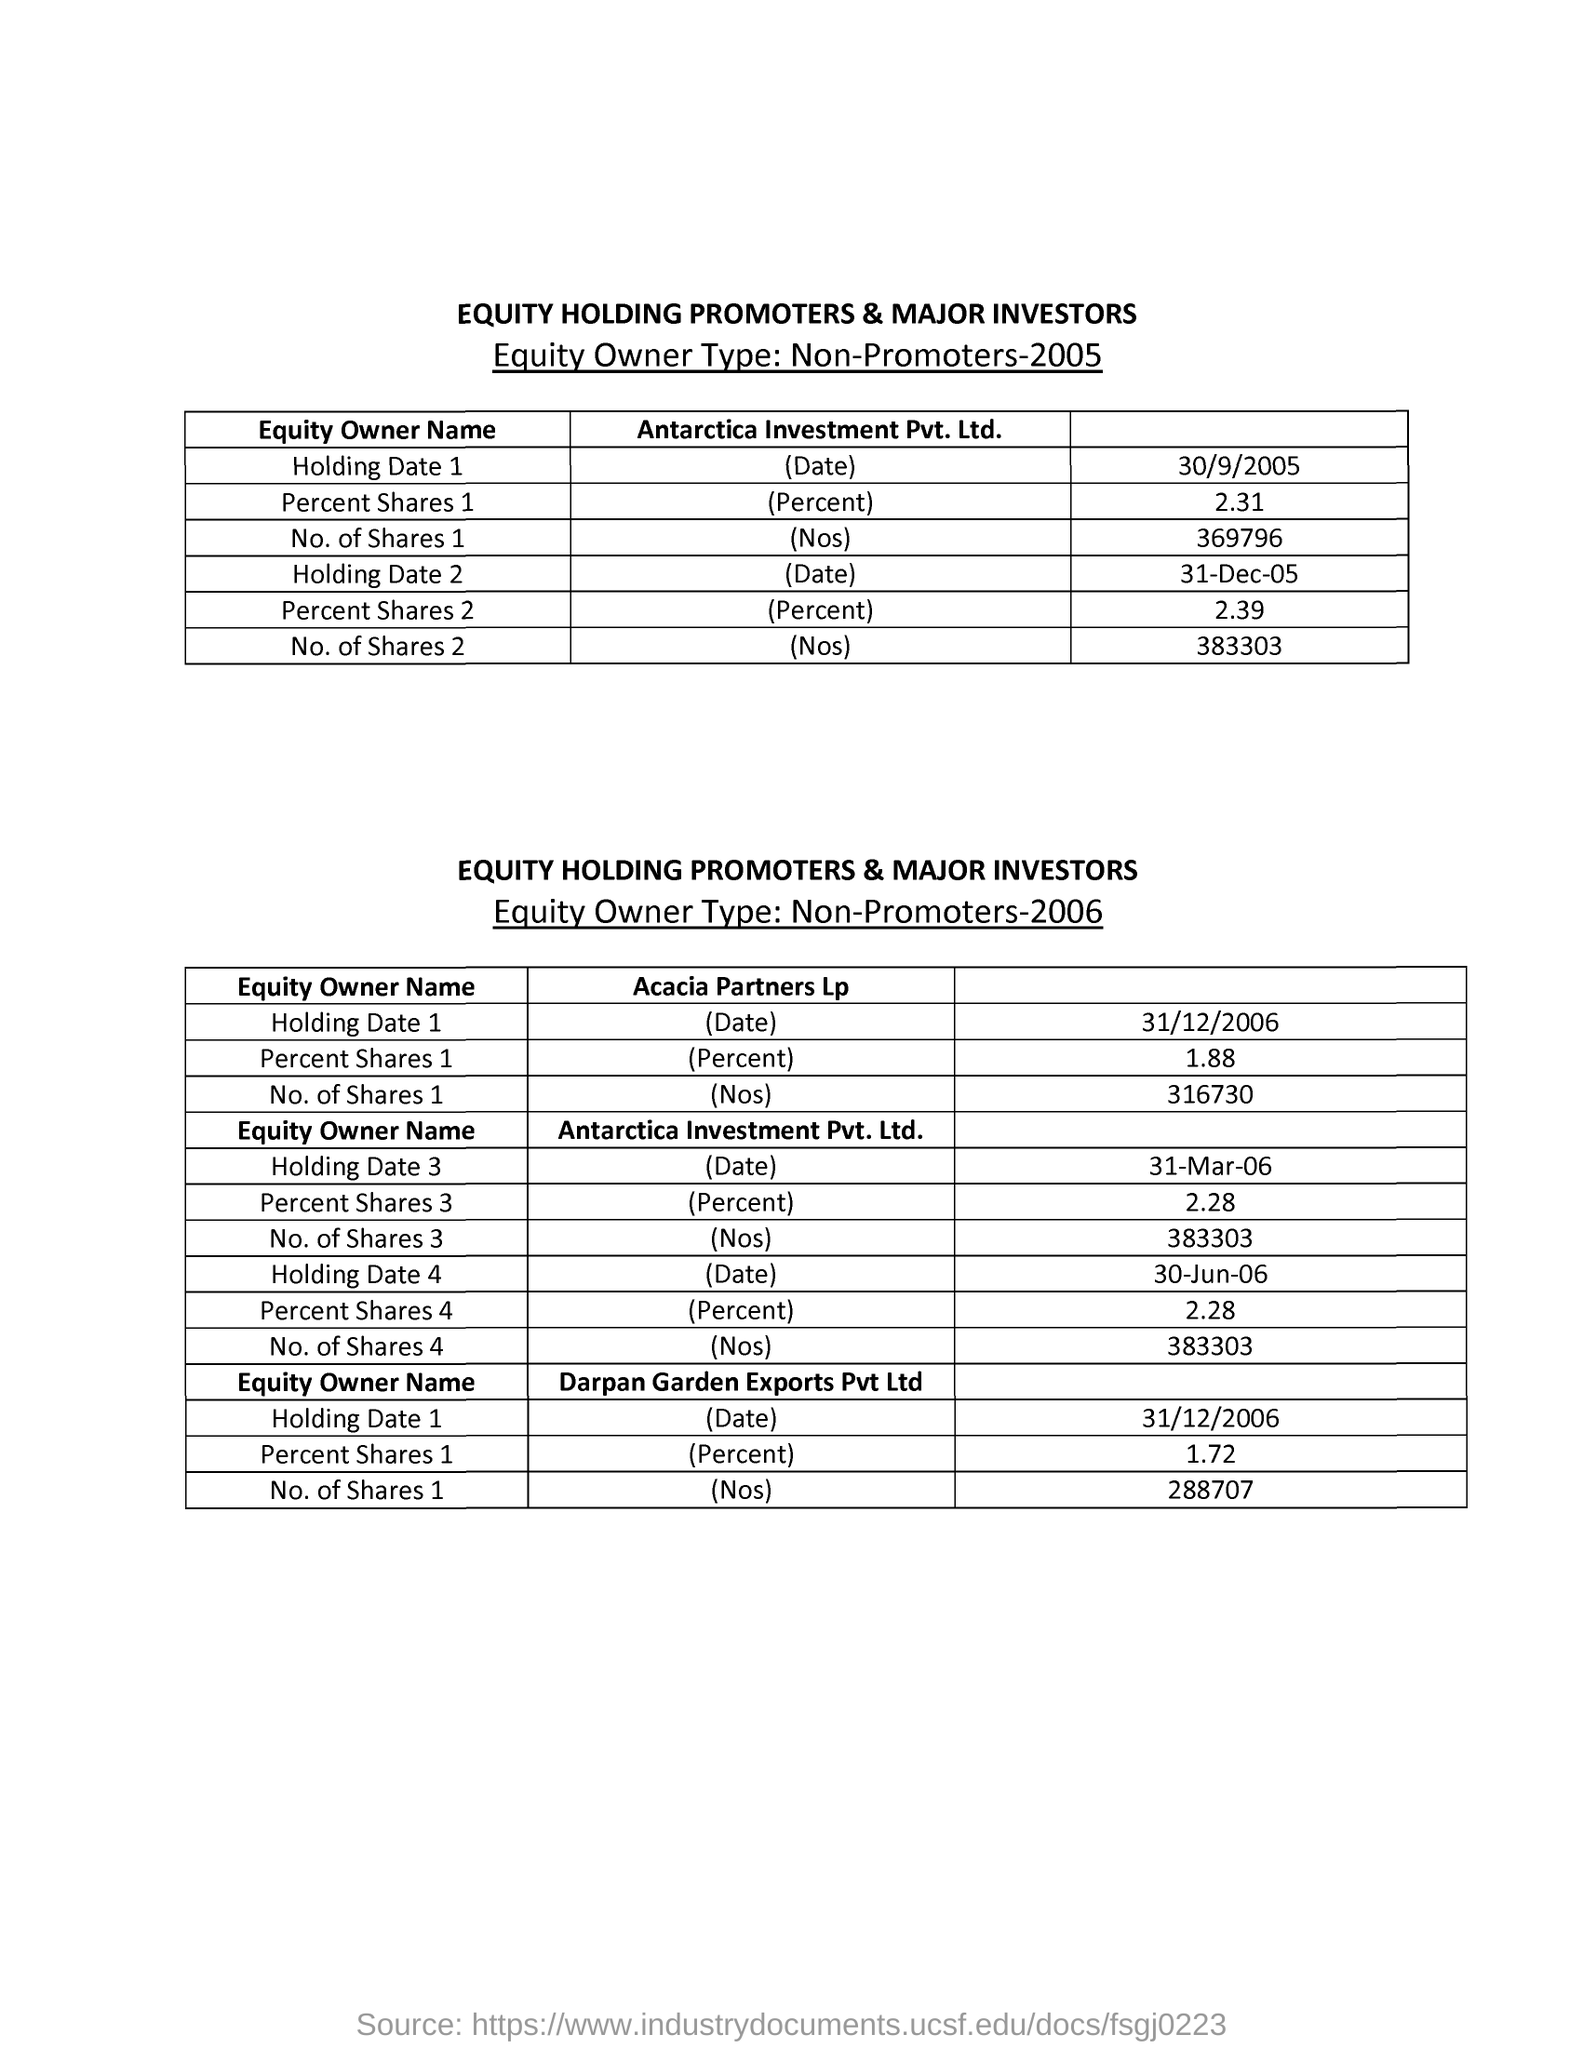What is the number of shares 2 of Antarctica Investment Pvt.Ltd.?
Offer a terse response. 383303. 